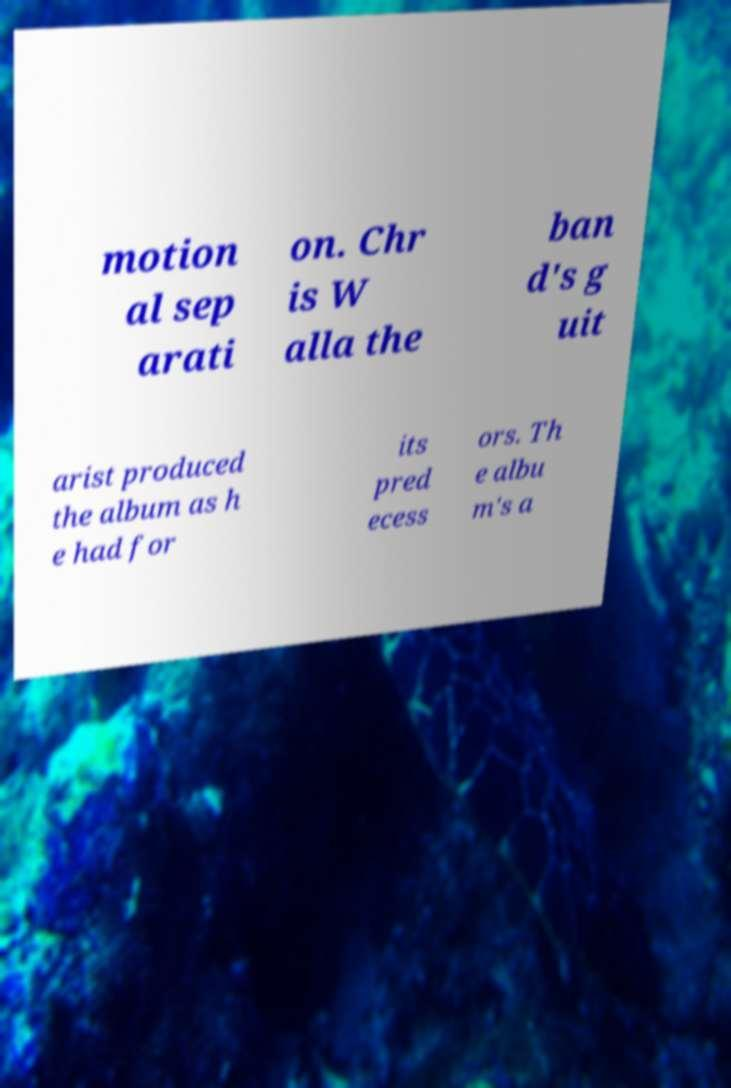Please read and relay the text visible in this image. What does it say? motion al sep arati on. Chr is W alla the ban d's g uit arist produced the album as h e had for its pred ecess ors. Th e albu m's a 